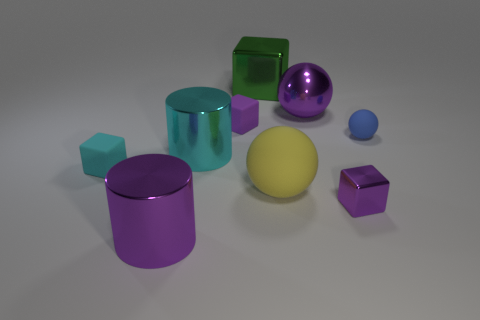Subtract 1 cubes. How many cubes are left? 3 Subtract all brown blocks. Subtract all gray balls. How many blocks are left? 4 Add 1 small blue matte things. How many objects exist? 10 Subtract all cylinders. How many objects are left? 7 Subtract 0 gray cylinders. How many objects are left? 9 Subtract all big green metallic balls. Subtract all small blue matte balls. How many objects are left? 8 Add 7 small rubber objects. How many small rubber objects are left? 10 Add 8 purple cylinders. How many purple cylinders exist? 9 